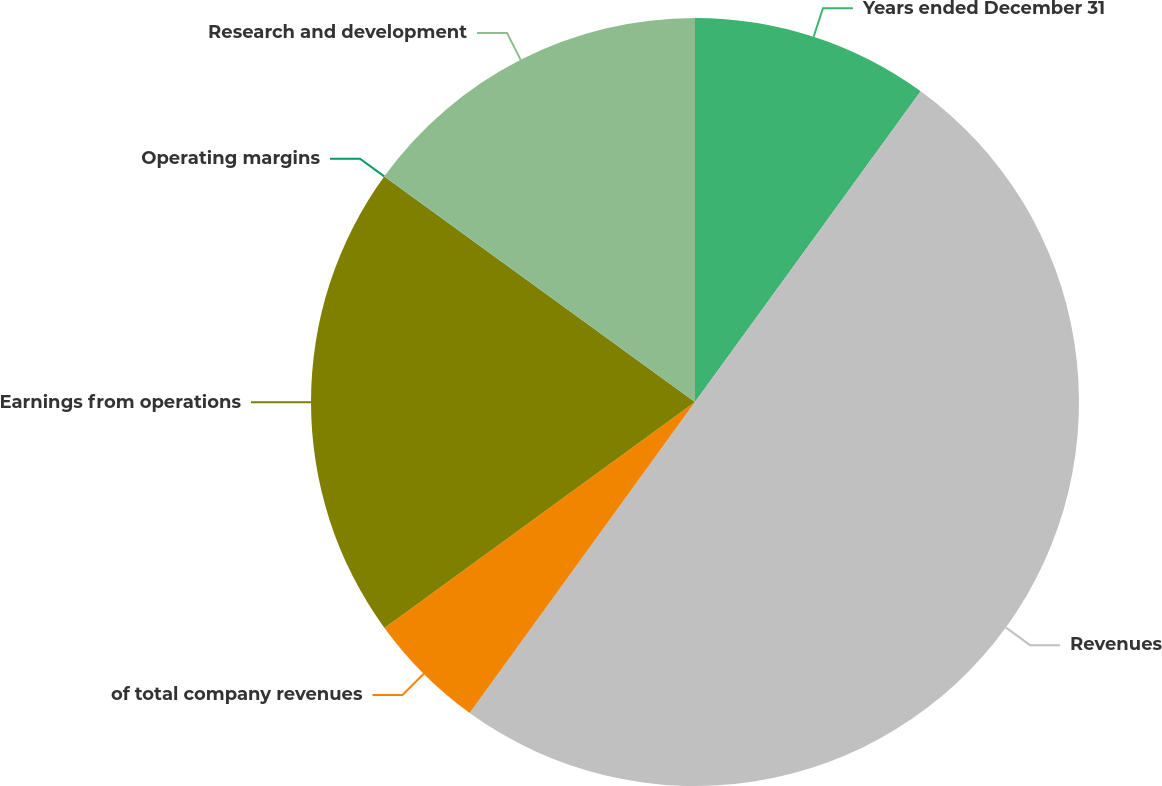Convert chart. <chart><loc_0><loc_0><loc_500><loc_500><pie_chart><fcel>Years ended December 31<fcel>Revenues<fcel>of total company revenues<fcel>Earnings from operations<fcel>Operating margins<fcel>Research and development<nl><fcel>10.0%<fcel>49.98%<fcel>5.01%<fcel>20.0%<fcel>0.01%<fcel>15.0%<nl></chart> 